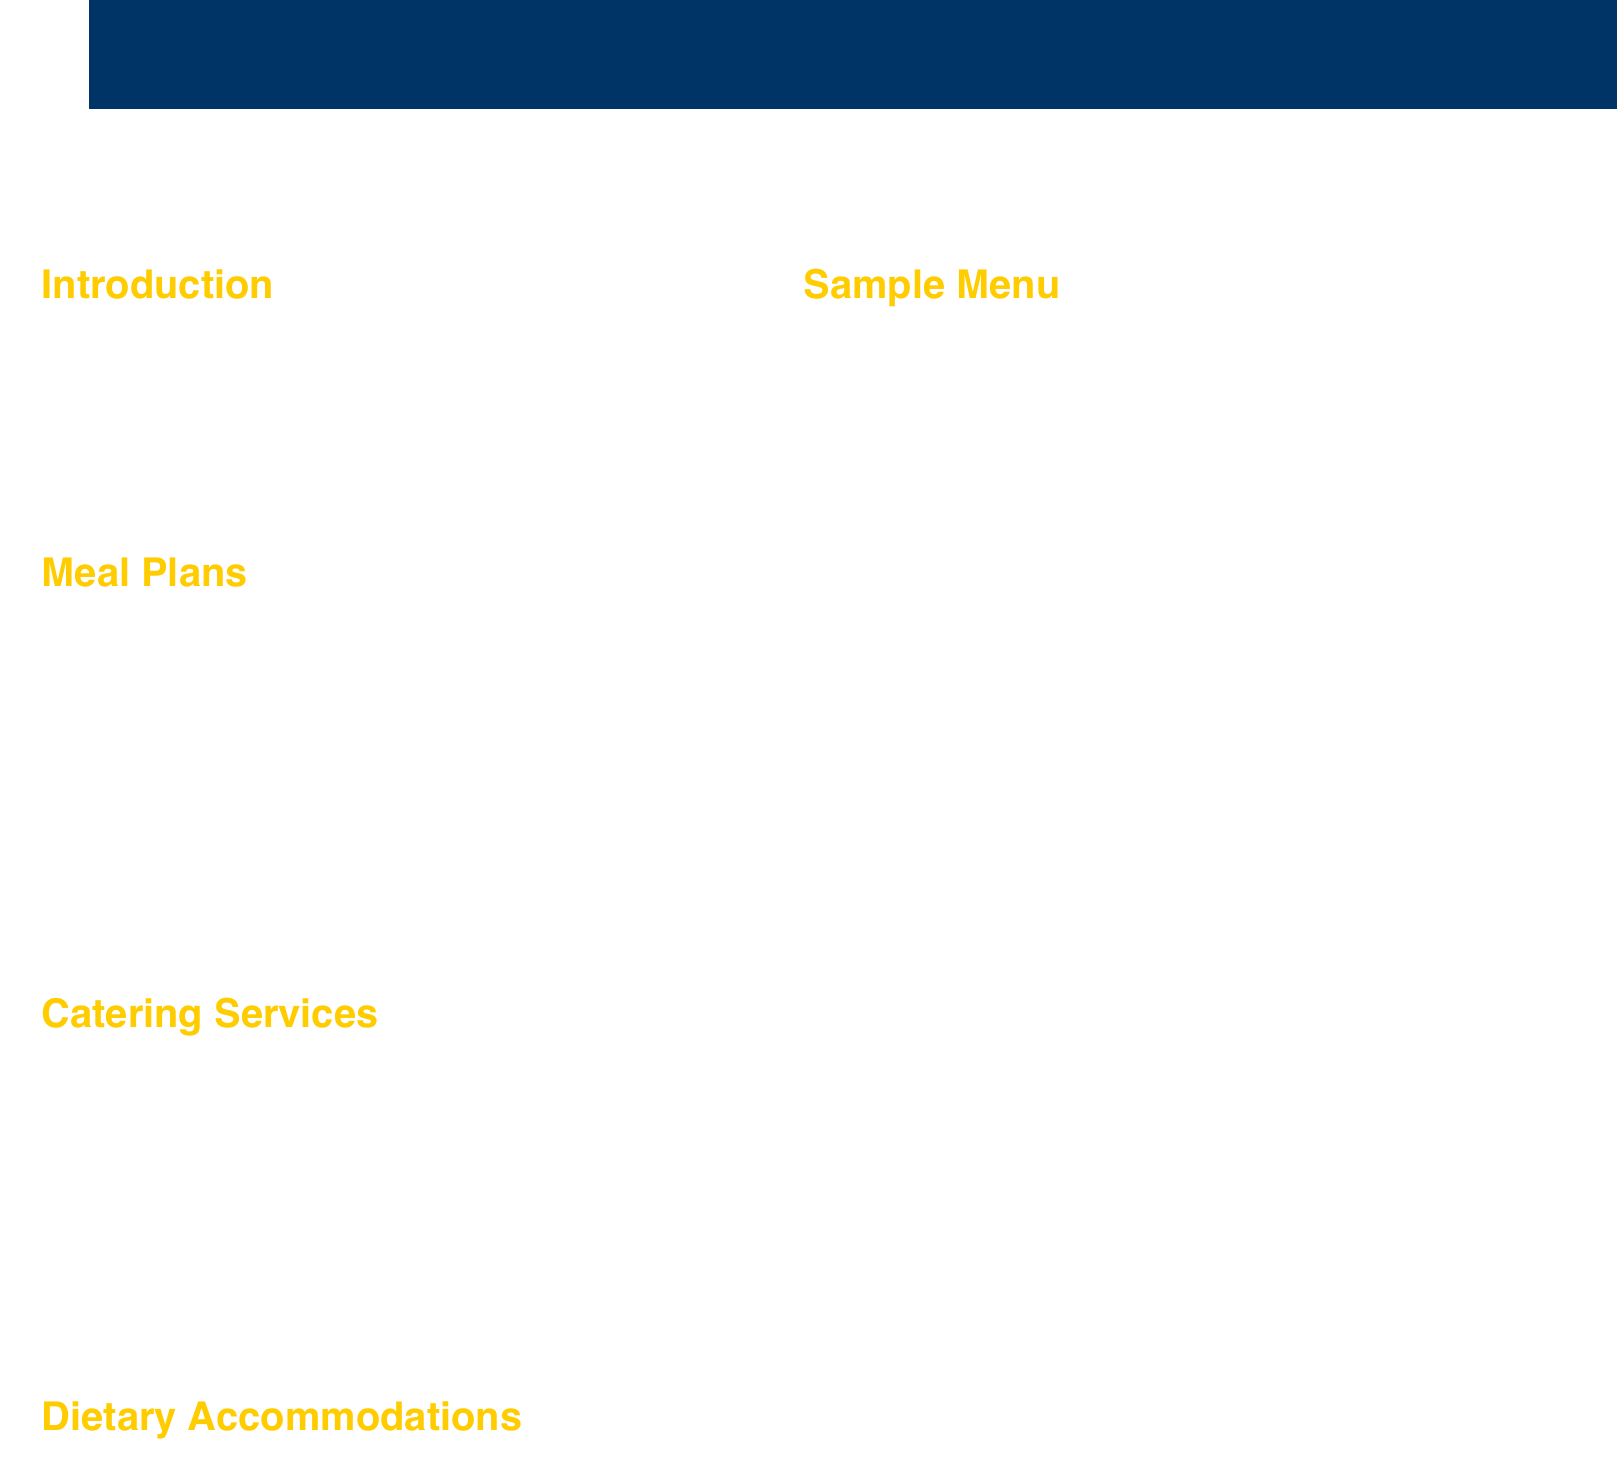what is the price of the Full Tournament Package? The price for the Full Tournament Package is listed in the Meal Plans section of the document.
Answer: $120 per person what types of dietary accommodations are offered? The types of dietary accommodations are mentioned in the Catering Services section of the document.
Answer: Vegetarian, Vegan, Gluten-free, Halal, Kosher who is the Catering Coordinator? The document provides contact information at the end, including the name of the Catering Coordinator.
Answer: Sarah Thompson what is included in the lunch menu? The document provides a Sample Menu that outlines the components of the lunch meal.
Answer: Deli sandwich platters, mixed green salad, pasta salad, chips, and cookies how many meals are provided in the Lunch & Dinner Plan? The number of meals included in the Lunch & Dinner Plan is specified in the Meal Plans section of the document.
Answer: Two meals per day which catering service offers made-to-order crepes? The available catering services are listed with their specialties in the Catering Services section.
Answer: Geneva Crepes what is the contact email for the Catering Coordinator? The contact information section provides the email address of the Catering Coordinator.
Answer: thompson@hws.edu what is the price for the À la carte meal option? The document states the pricing strategy for the À la carte option in the Meal Plans section but does not provide a specific price.
Answer: Varies 